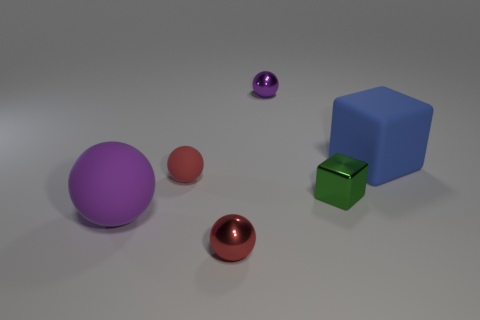Is the number of red things greater than the number of matte cylinders?
Give a very brief answer. Yes. Do the big object in front of the blue matte cube and the small purple thing have the same shape?
Your answer should be compact. Yes. Is the number of purple shiny things less than the number of tiny red balls?
Provide a short and direct response. Yes. There is another thing that is the same size as the purple matte object; what is it made of?
Offer a very short reply. Rubber. There is a tiny metal block; does it have the same color as the large thing on the right side of the tiny rubber thing?
Keep it short and to the point. No. Are there fewer small metal blocks that are to the right of the big matte block than green blocks?
Offer a very short reply. Yes. How many matte things are there?
Your answer should be compact. 3. What shape is the large rubber object that is right of the thing behind the big blue matte thing?
Offer a terse response. Cube. There is a tiny red matte sphere; how many red balls are behind it?
Give a very brief answer. 0. Are the small purple ball and the big object in front of the large blue thing made of the same material?
Make the answer very short. No. 